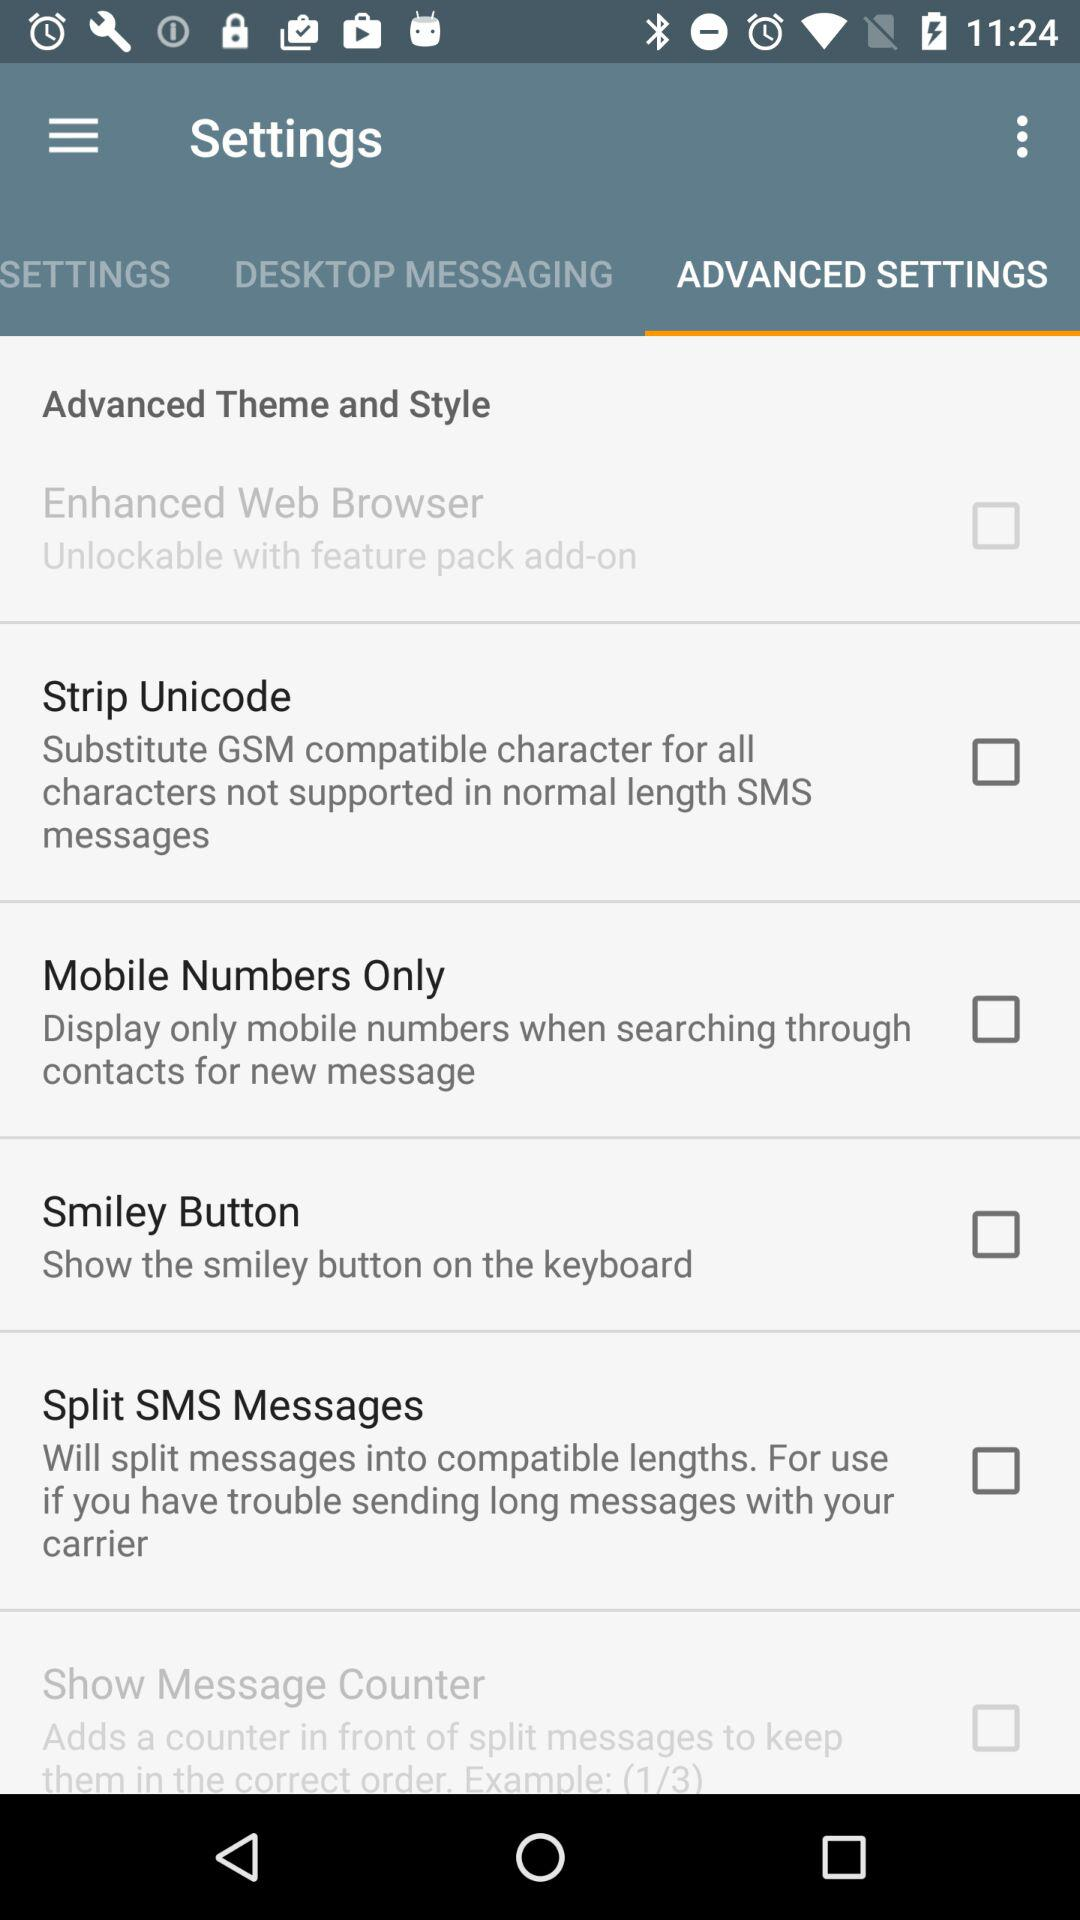What is the selected option in the "Settings"? The selected option is "ADVANCED SETTINGS". 